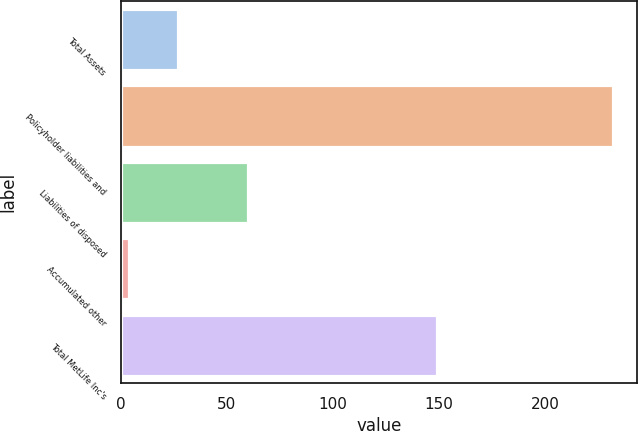Convert chart to OTSL. <chart><loc_0><loc_0><loc_500><loc_500><bar_chart><fcel>Total Assets<fcel>Policyholder liabilities and<fcel>Liabilities of disposed<fcel>Accumulated other<fcel>Total MetLife Inc's<nl><fcel>26.8<fcel>232<fcel>60<fcel>4<fcel>149<nl></chart> 